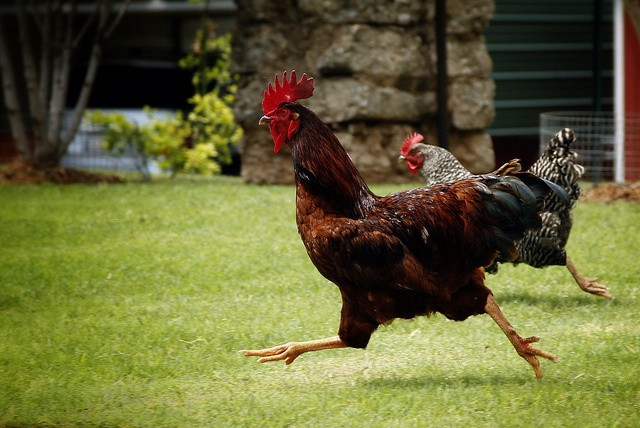Describe the objects in this image and their specific colors. I can see bird in black, maroon, and brown tones and bird in black, gray, darkgray, and darkgreen tones in this image. 